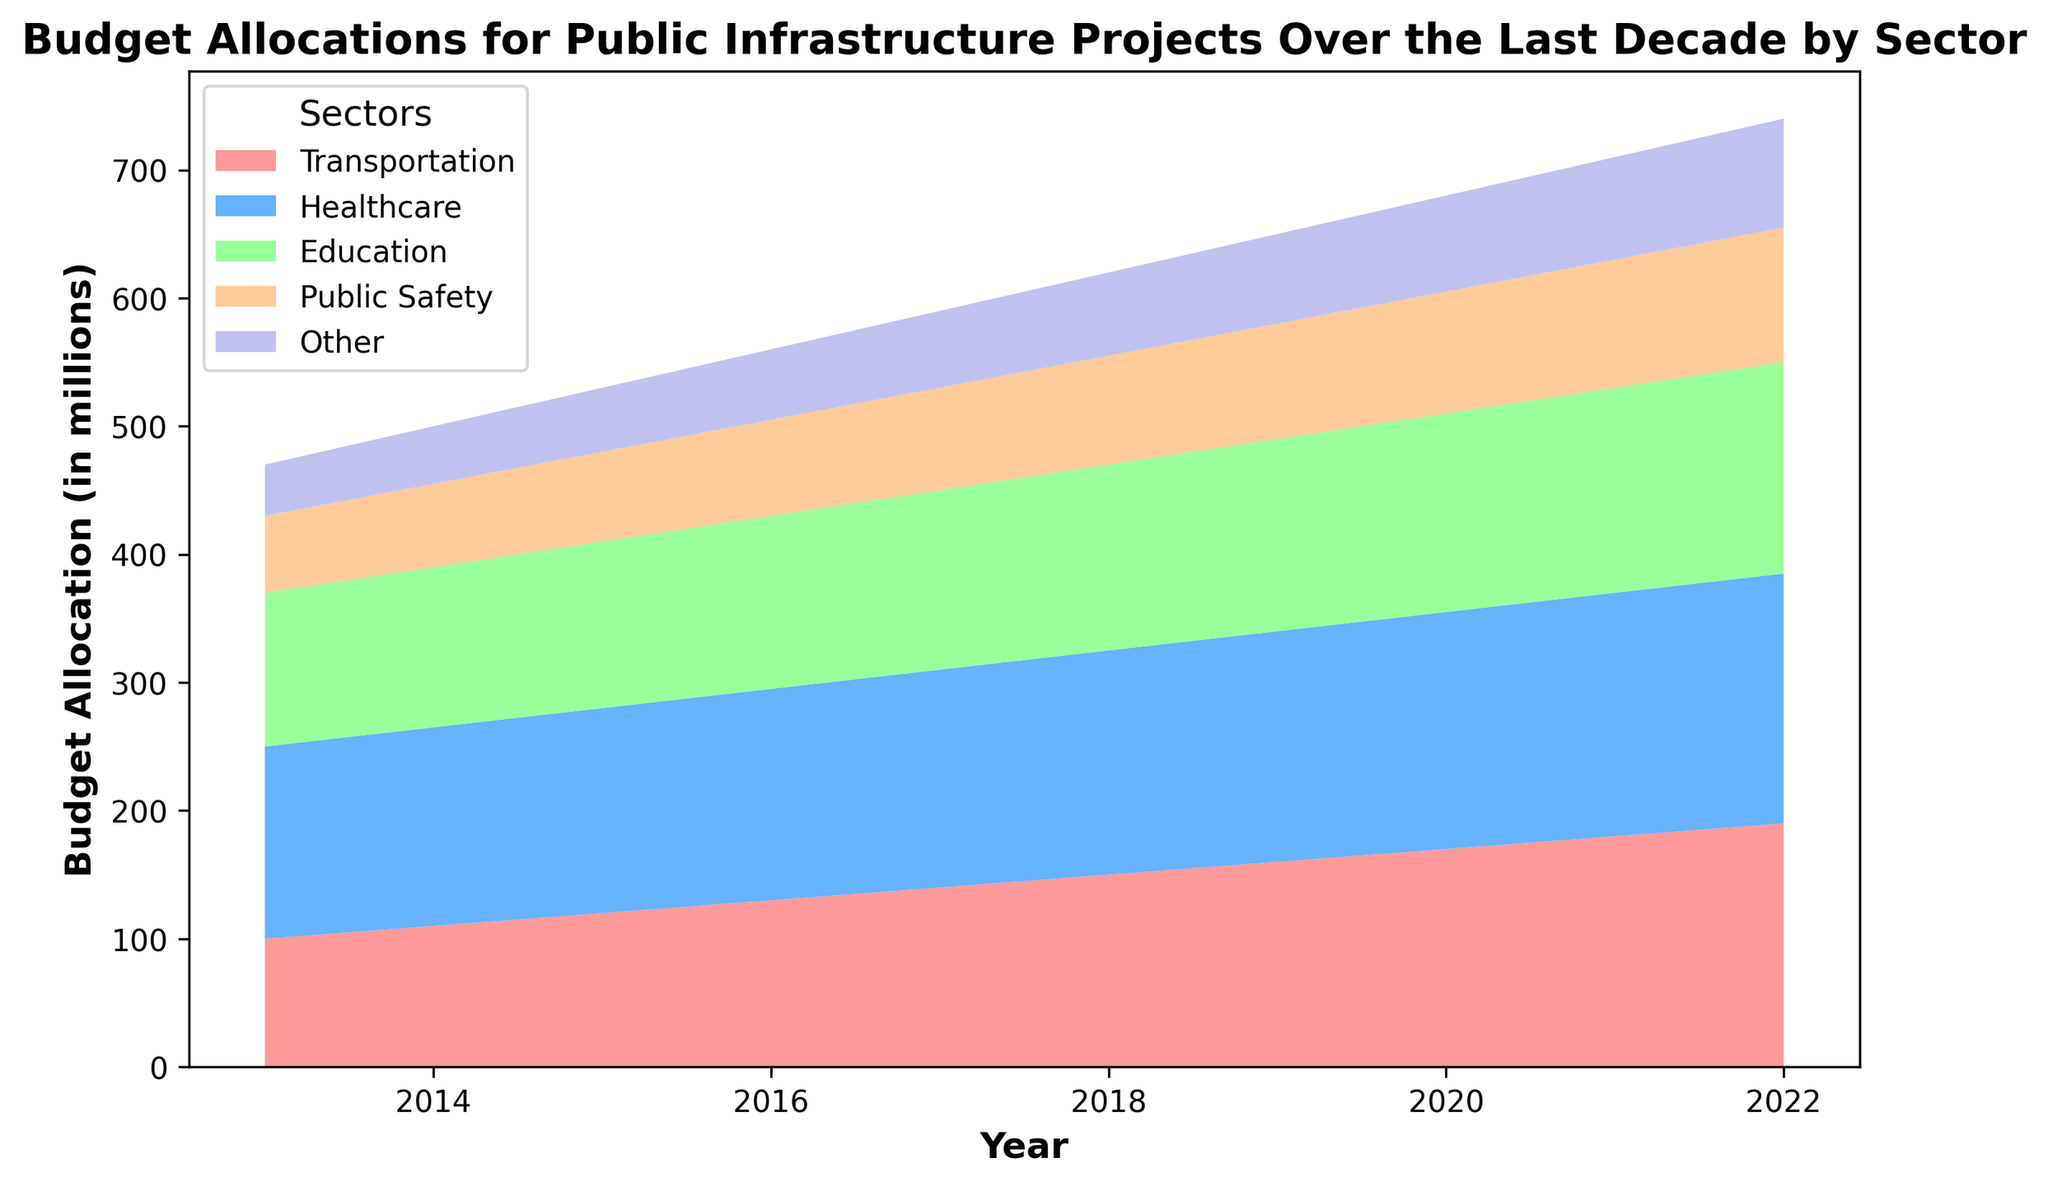Which sector has the highest budget allocation in 2022? Looking at the highest point on the Y-axis for each category in 2022, the highest-budget sector is Healthcare.
Answer: Healthcare Comparing 2014 and 2022, which sector's budget allocation increased the most? To find which sector increased their allocation the most, we need to calculate the difference between the 2022 and 2014 values for each sector. Healthcare increased from 155 to 195 (40 million), which is the largest increase.
Answer: Healthcare Which two sectors had the smallest aggregate budget increase from 2013 to 2022? Calculate the budget increase for each sector from 2013 to 2022 and sum them. The increases are Transportation (190-100=90), Healthcare (195-150=45), Education (165-120=45), Public Safety (105-60=45), and Other (85-40=45). The smallest aggregate increases are in Healthcare, Education, Public Safety, and Other, each with 45 million.
Answer: Healthcare, Education, Public Safety, Other Between which consecutive years did the budget allocation for Transportation see the highest increase? By calculating the increase in Transportation budget for each consecutive year, the highest increase occurred between 2021 and 2022, from 180 to 190 million (an increase of 10 million).
Answer: 2021-2022 What is the ratio of the budget allocation for Education to that of Public Safety in 2022? The budget for Education in 2022 is 165 million and for Public Safety, it's 105 million. The ratio is 165/105, which simplifies to approximately 1.57.
Answer: 1.57 By how much did the total budget allocation for all sectors change from 2013 to 2022? Sum the allocations for all sectors in 2013 (100+150+120+60+40=470) and 2022 (190+195+165+105+85=740). The change is 740 - 470 = 270 million.
Answer: 270 million In which year did Healthcare overtake Transportation in budget allocation? By examining the Y-axis values for both sectors, Healthcare first overtook Transportation in 2013.
Answer: 2013 Which sector's budget allocation had the steadiest year-over-year increase? By comparing the year-over-year changes for each sector, Healthcare increased consistently by 5 million each year, making it the steadiest.
Answer: Healthcare From 2013 to 2022, which year saw the highest combined increase in budget for all sectors? Calculation shows the sum of the combined budget increases year over year. The highest combined increase appears between 2021 and 2022, as there was a significant increase in each sector.
Answer: 2021-2022 